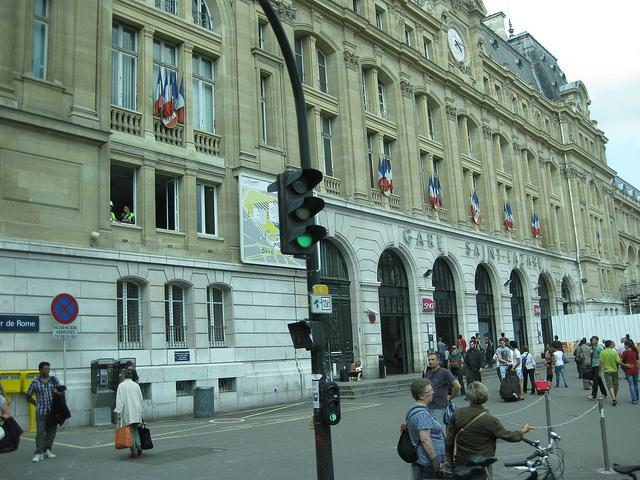What country's flag is being flown? Please explain your reasoning. france. The flag is red, white, and blue. it does not have crosses. 